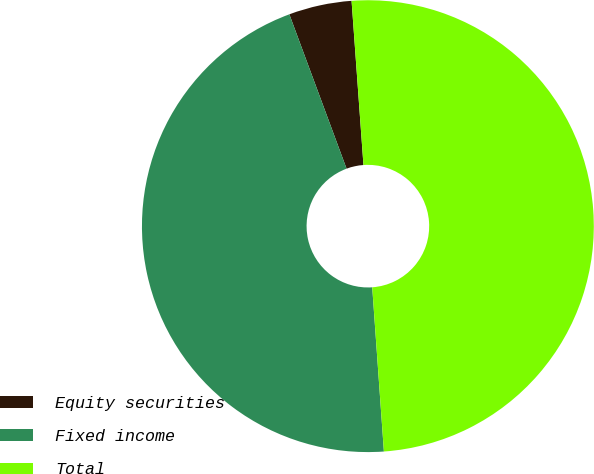<chart> <loc_0><loc_0><loc_500><loc_500><pie_chart><fcel>Equity securities<fcel>Fixed income<fcel>Total<nl><fcel>4.5%<fcel>45.48%<fcel>50.02%<nl></chart> 